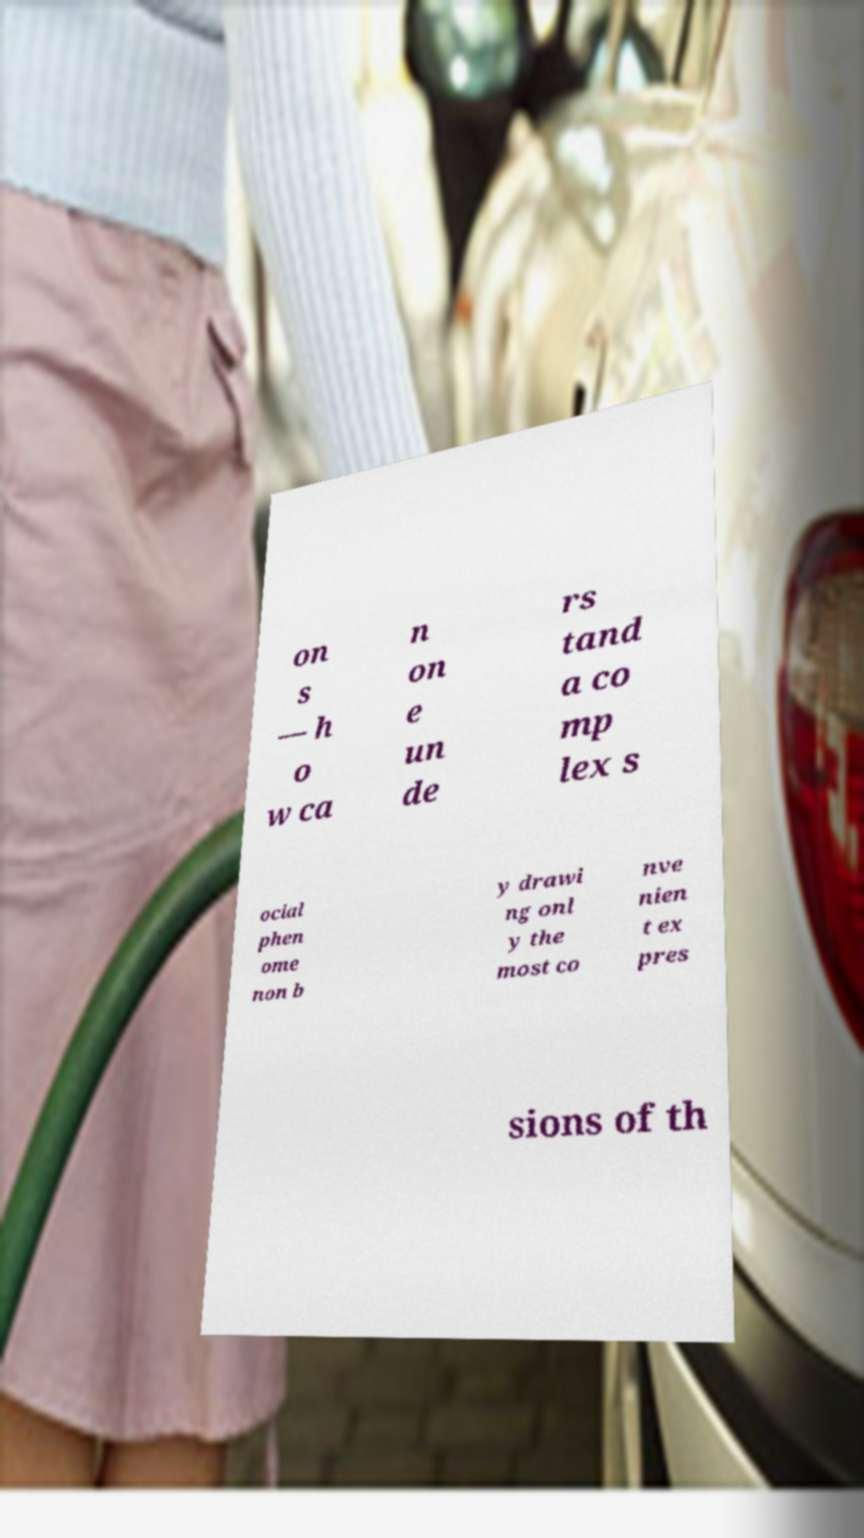Can you read and provide the text displayed in the image?This photo seems to have some interesting text. Can you extract and type it out for me? on s — h o w ca n on e un de rs tand a co mp lex s ocial phen ome non b y drawi ng onl y the most co nve nien t ex pres sions of th 